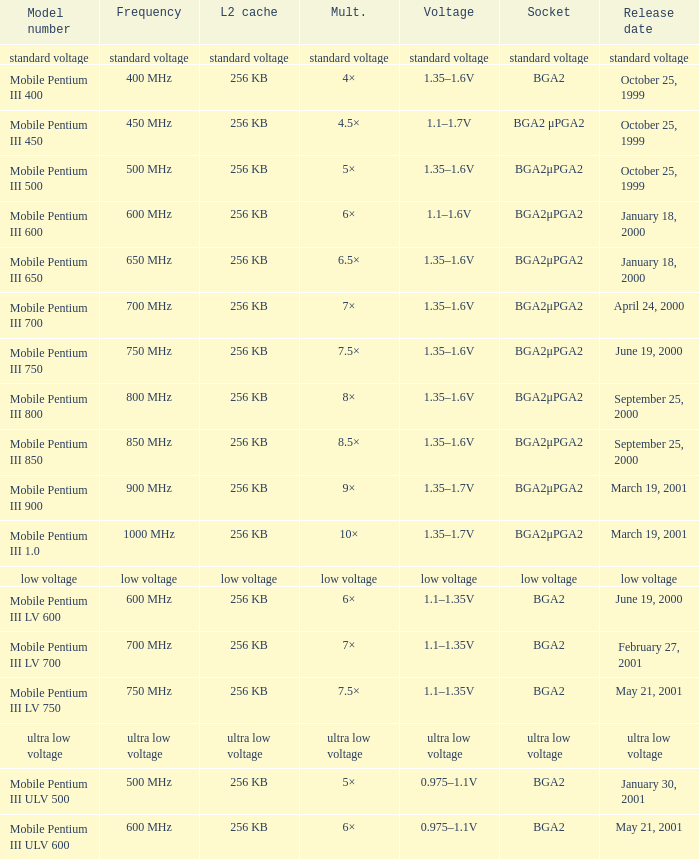What model number uses standard voltage socket? Standard voltage. Would you be able to parse every entry in this table? {'header': ['Model number', 'Frequency', 'L2 cache', 'Mult.', 'Voltage', 'Socket', 'Release date'], 'rows': [['standard voltage', 'standard voltage', 'standard voltage', 'standard voltage', 'standard voltage', 'standard voltage', 'standard voltage'], ['Mobile Pentium III 400', '400 MHz', '256 KB', '4×', '1.35–1.6V', 'BGA2', 'October 25, 1999'], ['Mobile Pentium III 450', '450 MHz', '256 KB', '4.5×', '1.1–1.7V', 'BGA2 μPGA2', 'October 25, 1999'], ['Mobile Pentium III 500', '500 MHz', '256 KB', '5×', '1.35–1.6V', 'BGA2μPGA2', 'October 25, 1999'], ['Mobile Pentium III 600', '600 MHz', '256 KB', '6×', '1.1–1.6V', 'BGA2μPGA2', 'January 18, 2000'], ['Mobile Pentium III 650', '650 MHz', '256 KB', '6.5×', '1.35–1.6V', 'BGA2μPGA2', 'January 18, 2000'], ['Mobile Pentium III 700', '700 MHz', '256 KB', '7×', '1.35–1.6V', 'BGA2μPGA2', 'April 24, 2000'], ['Mobile Pentium III 750', '750 MHz', '256 KB', '7.5×', '1.35–1.6V', 'BGA2μPGA2', 'June 19, 2000'], ['Mobile Pentium III 800', '800 MHz', '256 KB', '8×', '1.35–1.6V', 'BGA2μPGA2', 'September 25, 2000'], ['Mobile Pentium III 850', '850 MHz', '256 KB', '8.5×', '1.35–1.6V', 'BGA2μPGA2', 'September 25, 2000'], ['Mobile Pentium III 900', '900 MHz', '256 KB', '9×', '1.35–1.7V', 'BGA2μPGA2', 'March 19, 2001'], ['Mobile Pentium III 1.0', '1000 MHz', '256 KB', '10×', '1.35–1.7V', 'BGA2μPGA2', 'March 19, 2001'], ['low voltage', 'low voltage', 'low voltage', 'low voltage', 'low voltage', 'low voltage', 'low voltage'], ['Mobile Pentium III LV 600', '600 MHz', '256 KB', '6×', '1.1–1.35V', 'BGA2', 'June 19, 2000'], ['Mobile Pentium III LV 700', '700 MHz', '256 KB', '7×', '1.1–1.35V', 'BGA2', 'February 27, 2001'], ['Mobile Pentium III LV 750', '750 MHz', '256 KB', '7.5×', '1.1–1.35V', 'BGA2', 'May 21, 2001'], ['ultra low voltage', 'ultra low voltage', 'ultra low voltage', 'ultra low voltage', 'ultra low voltage', 'ultra low voltage', 'ultra low voltage'], ['Mobile Pentium III ULV 500', '500 MHz', '256 KB', '5×', '0.975–1.1V', 'BGA2', 'January 30, 2001'], ['Mobile Pentium III ULV 600', '600 MHz', '256 KB', '6×', '0.975–1.1V', 'BGA2', 'May 21, 2001']]} 